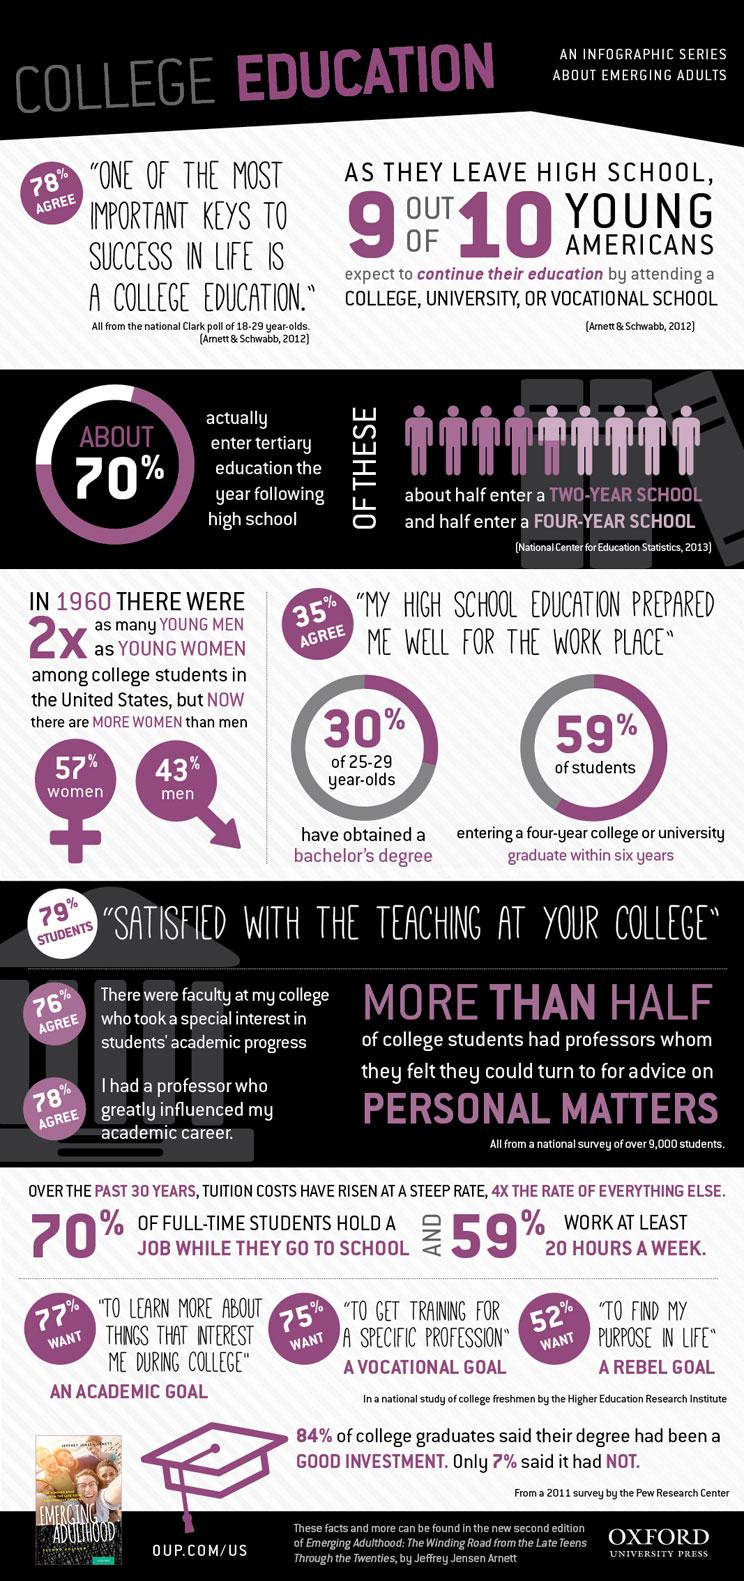Outline some significant characteristics in this image. According to statistics, 30% of students in the age range of 25-29 have obtained a bachelor's degree. According to a survey, 1% of Americans do not believe that they can continue their education by attending a college. According to a recent survey, it was found that 43% of American college students are men. According to recent studies, approximately 30% of Americans do not pursue a tertiary education after completing high school. According to a survey, 65% of Americans do not believe that their school education adequately prepared them for the demands of the workplace. 